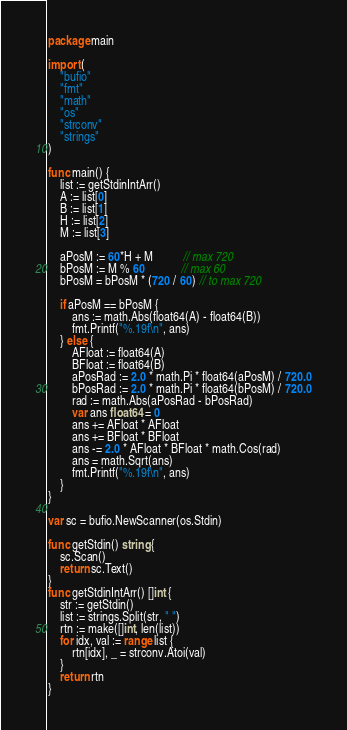Convert code to text. <code><loc_0><loc_0><loc_500><loc_500><_Go_>package main

import (
	"bufio"
	"fmt"
	"math"
	"os"
	"strconv"
	"strings"
)

func main() {
	list := getStdinIntArr()
	A := list[0]
	B := list[1]
	H := list[2]
	M := list[3]

	aPosM := 60*H + M          // max 720
	bPosM := M % 60            // max 60
	bPosM = bPosM * (720 / 60) // to max 720

	if aPosM == bPosM {
		ans := math.Abs(float64(A) - float64(B))
		fmt.Printf("%.19f\n", ans)
	} else {
		AFloat := float64(A)
		BFloat := float64(B)
		aPosRad := 2.0 * math.Pi * float64(aPosM) / 720.0
		bPosRad := 2.0 * math.Pi * float64(bPosM) / 720.0
		rad := math.Abs(aPosRad - bPosRad)
		var ans float64 = 0
		ans += AFloat * AFloat
		ans += BFloat * BFloat
		ans -= 2.0 * AFloat * BFloat * math.Cos(rad)
		ans = math.Sqrt(ans)
		fmt.Printf("%.19f\n", ans)
	}
}

var sc = bufio.NewScanner(os.Stdin)

func getStdin() string {
	sc.Scan()
	return sc.Text()
}
func getStdinIntArr() []int {
	str := getStdin()
	list := strings.Split(str, " ")
	rtn := make([]int, len(list))
	for idx, val := range list {
		rtn[idx], _ = strconv.Atoi(val)
	}
	return rtn
}
</code> 